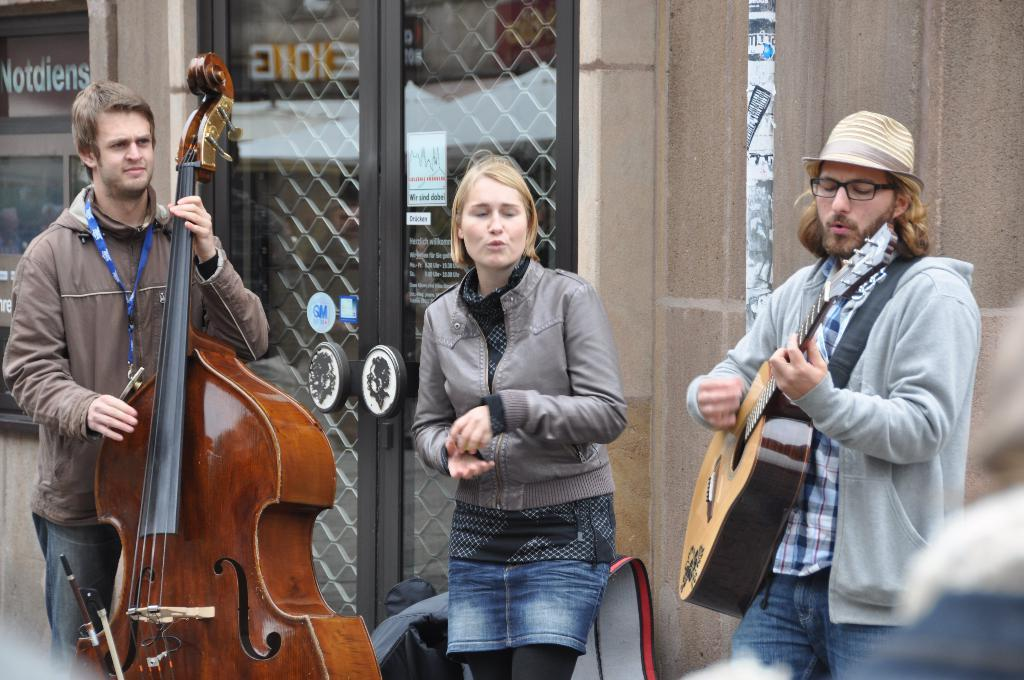How many people are in the image? There are three people in the image. What are two of the people doing in the image? Two of the people are playing guitars. What can be seen in the background of the image? There is a building and a pole visible in the background of the image. What feature of the building is mentioned in the facts? The building has doors. What type of trouble is the parent causing in the image? There is no parent or trouble present in the image. What is the hose used for in the image? There is no hose present in the image. 